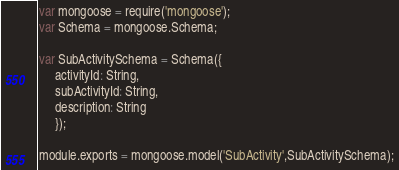Convert code to text. <code><loc_0><loc_0><loc_500><loc_500><_JavaScript_>
var mongoose = require('mongoose');
var Schema = mongoose.Schema;

var SubActivitySchema = Schema({
	 activityId: String,
	 subActivityId: String,
	 description: String
	 });

module.exports = mongoose.model('SubActivity',SubActivitySchema);</code> 